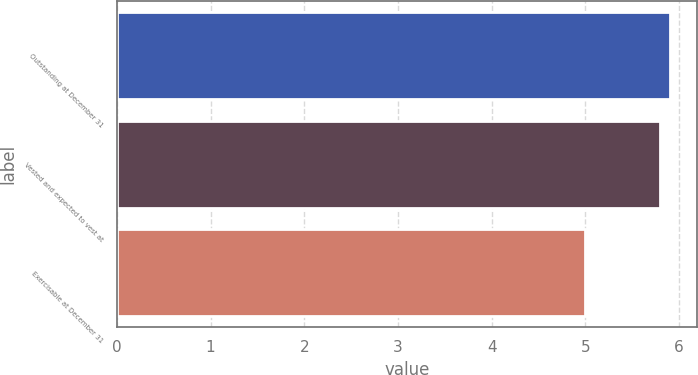Convert chart to OTSL. <chart><loc_0><loc_0><loc_500><loc_500><bar_chart><fcel>Outstanding at December 31<fcel>Vested and expected to vest at<fcel>Exercisable at December 31<nl><fcel>5.9<fcel>5.8<fcel>5<nl></chart> 